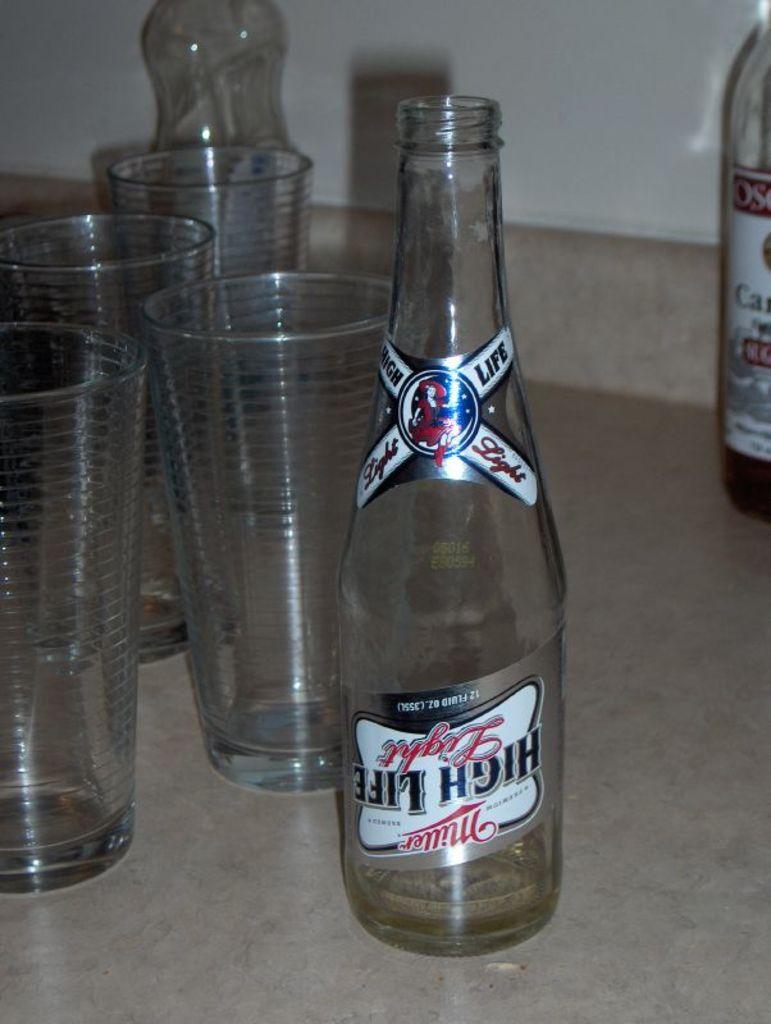What brand of beer was in this bottle?
Provide a short and direct response. Miller. 